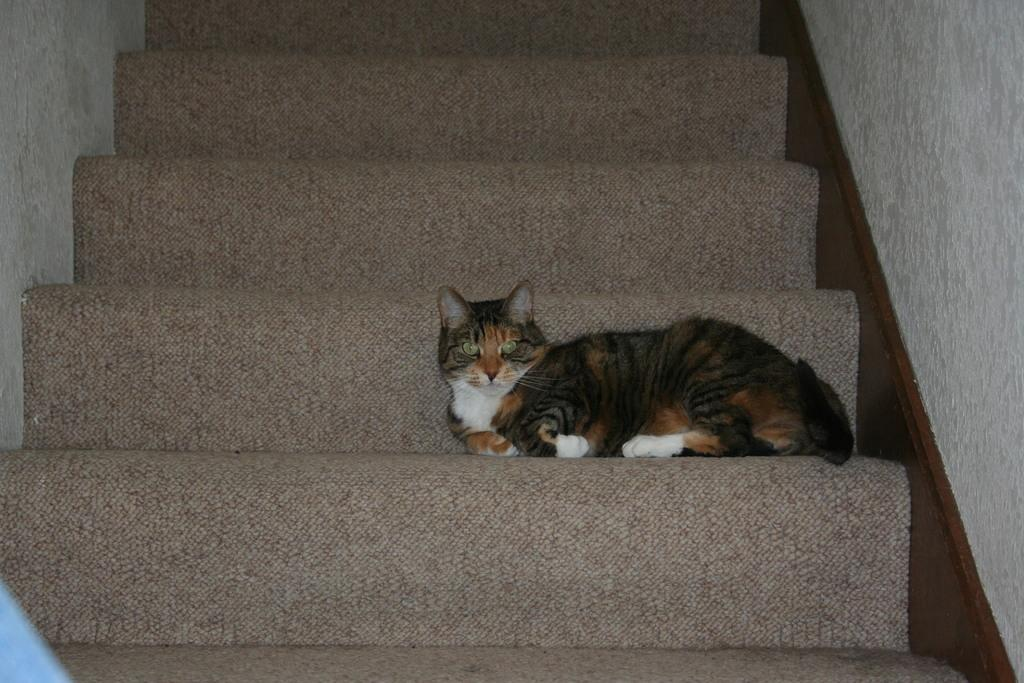What animal is present in the image? There is a cat in the image. Where is the cat located? The cat is on the stairs. What can be seen in the background of the image? There is a wall in the background of the image. How many sheep are visible in the image? There are no sheep present in the image. What type of action is the cat performing in the image? The image does not show the cat performing any specific action; it is simply sitting on the stairs. 